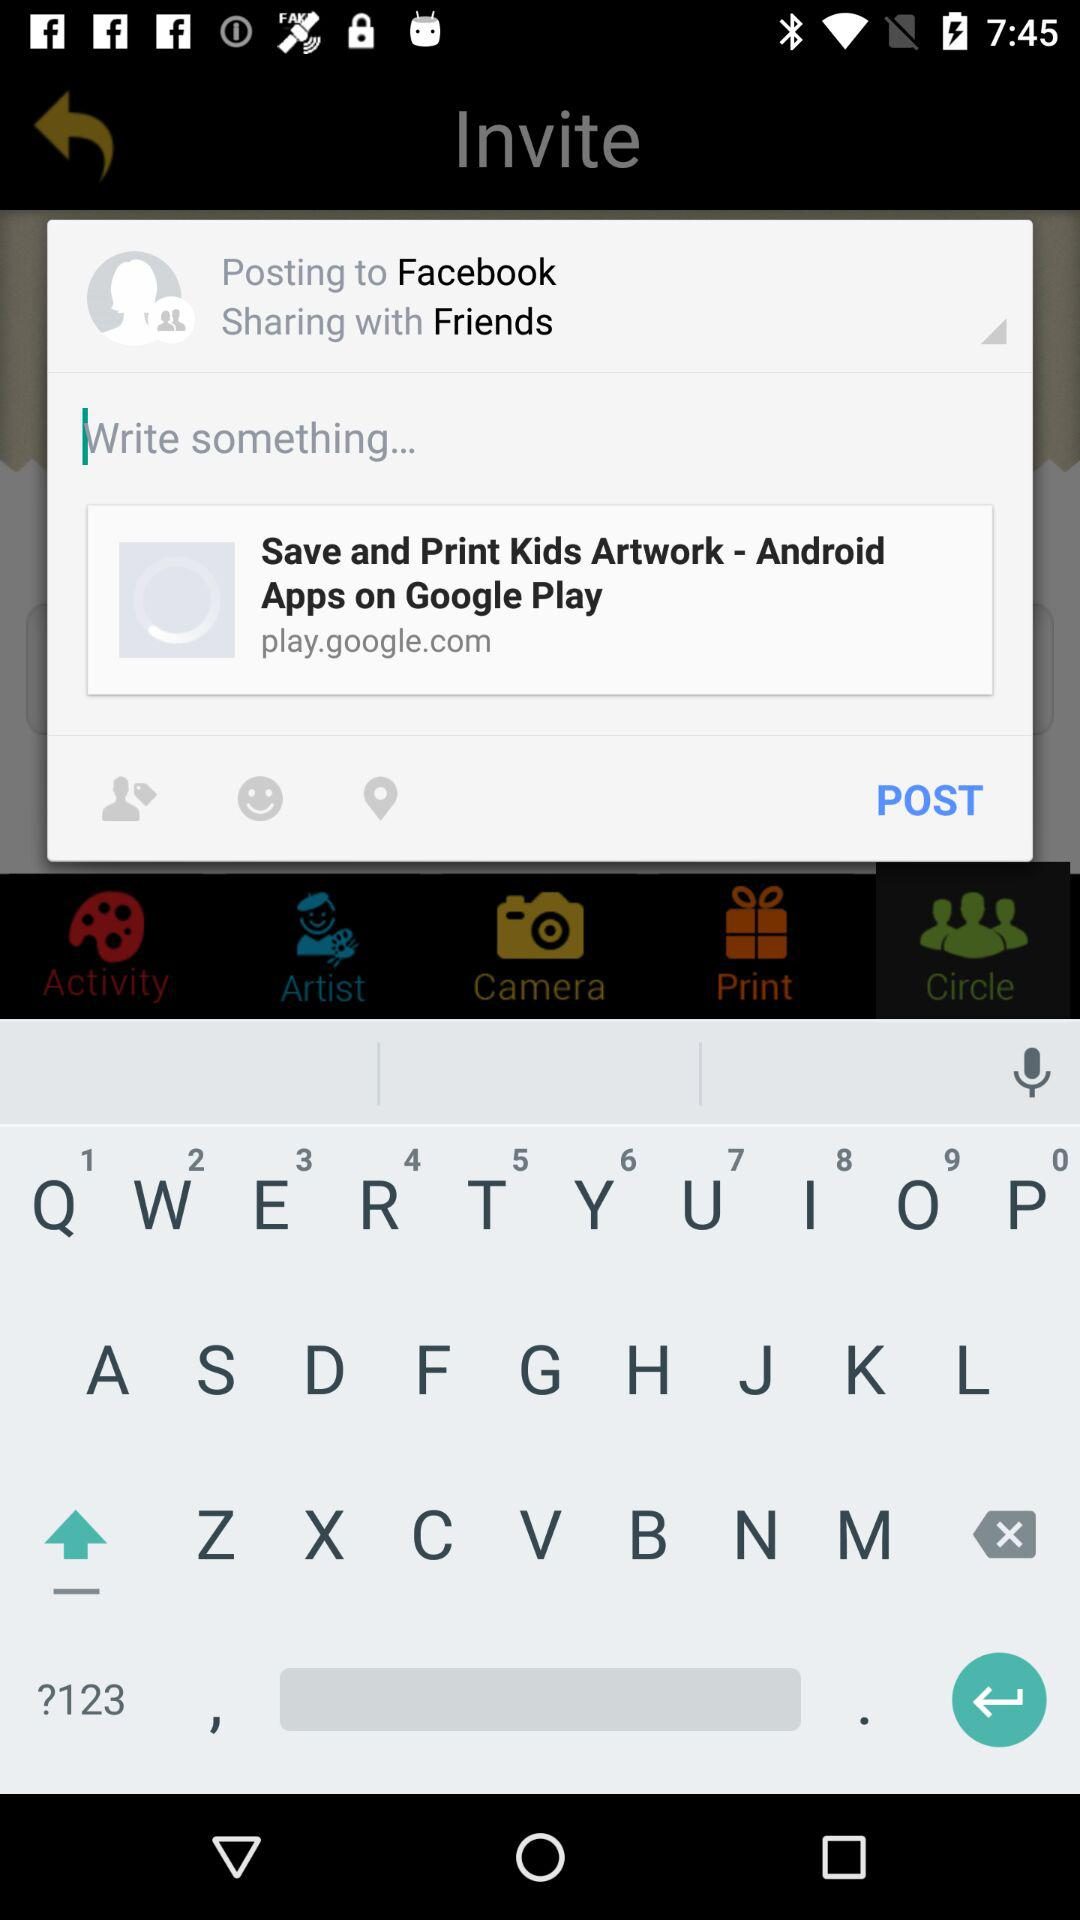What month is it? It is the month of May. 